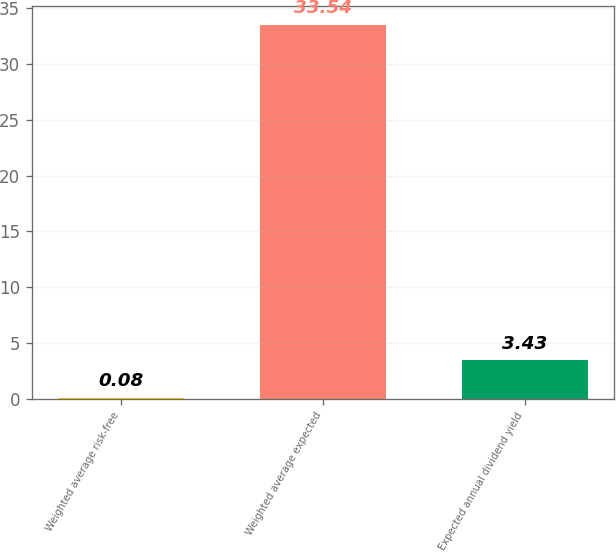<chart> <loc_0><loc_0><loc_500><loc_500><bar_chart><fcel>Weighted average risk-free<fcel>Weighted average expected<fcel>Expected annual dividend yield<nl><fcel>0.08<fcel>33.54<fcel>3.43<nl></chart> 